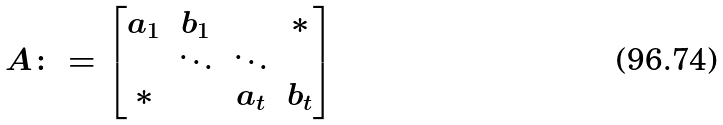<formula> <loc_0><loc_0><loc_500><loc_500>A \colon = \begin{bmatrix} a _ { 1 } & b _ { 1 } & & * \\ & \ddots & \ddots & \\ * & & a _ { t } & b _ { t } \\ \end{bmatrix}</formula> 